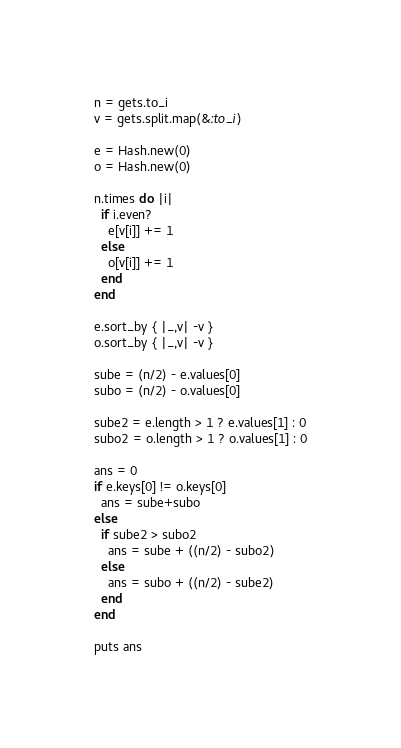Convert code to text. <code><loc_0><loc_0><loc_500><loc_500><_Ruby_>n = gets.to_i
v = gets.split.map(&:to_i)

e = Hash.new(0)
o = Hash.new(0)

n.times do |i|
  if i.even?
    e[v[i]] += 1
  else
    o[v[i]] += 1
  end
end

e.sort_by { |_,v| -v }
o.sort_by { |_,v| -v }

sube = (n/2) - e.values[0]
subo = (n/2) - o.values[0]

sube2 = e.length > 1 ? e.values[1] : 0
subo2 = o.length > 1 ? o.values[1] : 0

ans = 0
if e.keys[0] != o.keys[0]
  ans = sube+subo
else
  if sube2 > subo2
    ans = sube + ((n/2) - subo2)
  else
    ans = subo + ((n/2) - sube2)
  end
end

puts ans</code> 